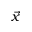<formula> <loc_0><loc_0><loc_500><loc_500>\vec { x }</formula> 